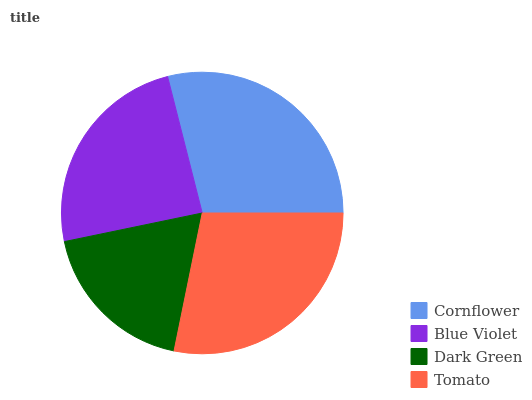Is Dark Green the minimum?
Answer yes or no. Yes. Is Cornflower the maximum?
Answer yes or no. Yes. Is Blue Violet the minimum?
Answer yes or no. No. Is Blue Violet the maximum?
Answer yes or no. No. Is Cornflower greater than Blue Violet?
Answer yes or no. Yes. Is Blue Violet less than Cornflower?
Answer yes or no. Yes. Is Blue Violet greater than Cornflower?
Answer yes or no. No. Is Cornflower less than Blue Violet?
Answer yes or no. No. Is Tomato the high median?
Answer yes or no. Yes. Is Blue Violet the low median?
Answer yes or no. Yes. Is Dark Green the high median?
Answer yes or no. No. Is Dark Green the low median?
Answer yes or no. No. 